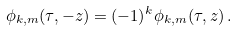Convert formula to latex. <formula><loc_0><loc_0><loc_500><loc_500>\phi _ { k , m } ( \tau , - z ) = ( - 1 ) ^ { k } \phi _ { k , m } ( \tau , z ) \, .</formula> 